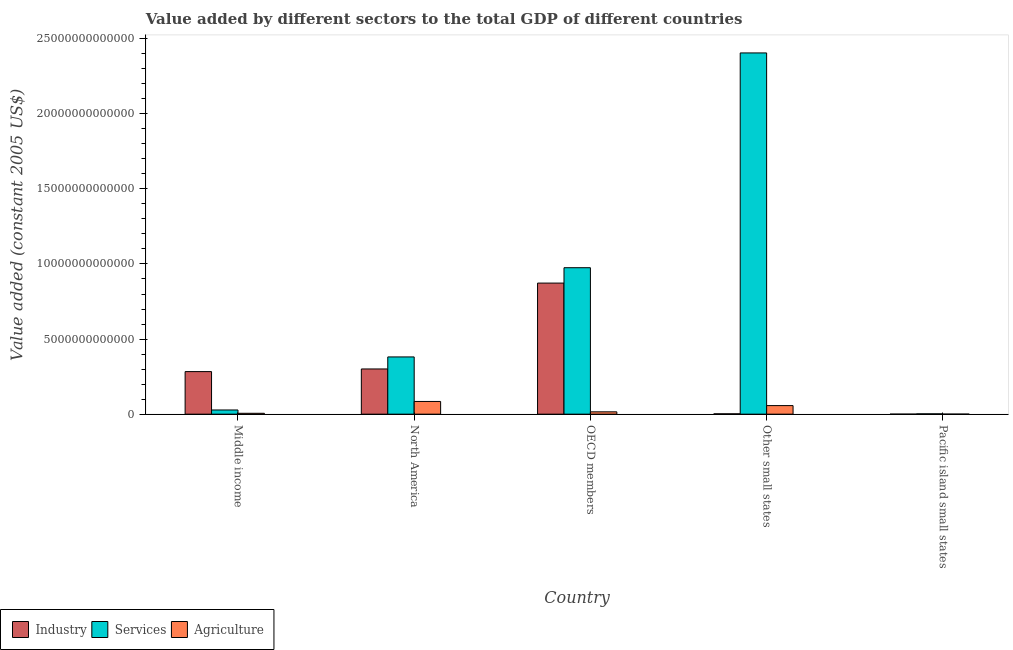How many different coloured bars are there?
Make the answer very short. 3. Are the number of bars per tick equal to the number of legend labels?
Your answer should be very brief. Yes. Are the number of bars on each tick of the X-axis equal?
Your response must be concise. Yes. How many bars are there on the 4th tick from the right?
Offer a very short reply. 3. What is the label of the 4th group of bars from the left?
Keep it short and to the point. Other small states. In how many cases, is the number of bars for a given country not equal to the number of legend labels?
Offer a terse response. 0. What is the value added by agricultural sector in Pacific island small states?
Make the answer very short. 3.43e+09. Across all countries, what is the maximum value added by industrial sector?
Give a very brief answer. 8.73e+12. Across all countries, what is the minimum value added by industrial sector?
Offer a terse response. 8.45e+08. In which country was the value added by agricultural sector maximum?
Provide a succinct answer. North America. In which country was the value added by industrial sector minimum?
Your answer should be compact. Pacific island small states. What is the total value added by agricultural sector in the graph?
Your answer should be very brief. 1.63e+12. What is the difference between the value added by industrial sector in North America and that in Pacific island small states?
Offer a terse response. 3.01e+12. What is the difference between the value added by industrial sector in Middle income and the value added by services in Other small states?
Give a very brief answer. -2.12e+13. What is the average value added by industrial sector per country?
Give a very brief answer. 2.92e+12. What is the difference between the value added by industrial sector and value added by agricultural sector in OECD members?
Provide a short and direct response. 8.57e+12. In how many countries, is the value added by services greater than 6000000000000 US$?
Provide a short and direct response. 2. What is the ratio of the value added by services in OECD members to that in Pacific island small states?
Your answer should be very brief. 452.85. Is the value added by services in OECD members less than that in Pacific island small states?
Offer a terse response. No. Is the difference between the value added by industrial sector in North America and Other small states greater than the difference between the value added by agricultural sector in North America and Other small states?
Offer a terse response. Yes. What is the difference between the highest and the second highest value added by services?
Offer a terse response. 1.43e+13. What is the difference between the highest and the lowest value added by agricultural sector?
Offer a very short reply. 8.42e+11. Is the sum of the value added by services in Middle income and North America greater than the maximum value added by industrial sector across all countries?
Your answer should be very brief. No. What does the 1st bar from the left in Pacific island small states represents?
Keep it short and to the point. Industry. What does the 1st bar from the right in Other small states represents?
Ensure brevity in your answer.  Agriculture. Is it the case that in every country, the sum of the value added by industrial sector and value added by services is greater than the value added by agricultural sector?
Give a very brief answer. Yes. Are all the bars in the graph horizontal?
Your answer should be compact. No. What is the difference between two consecutive major ticks on the Y-axis?
Your response must be concise. 5.00e+12. Does the graph contain any zero values?
Keep it short and to the point. No. Does the graph contain grids?
Provide a succinct answer. No. What is the title of the graph?
Ensure brevity in your answer.  Value added by different sectors to the total GDP of different countries. What is the label or title of the X-axis?
Provide a short and direct response. Country. What is the label or title of the Y-axis?
Offer a terse response. Value added (constant 2005 US$). What is the Value added (constant 2005 US$) in Industry in Middle income?
Offer a very short reply. 2.83e+12. What is the Value added (constant 2005 US$) of Services in Middle income?
Offer a terse response. 2.78e+11. What is the Value added (constant 2005 US$) of Agriculture in Middle income?
Provide a short and direct response. 5.82e+1. What is the Value added (constant 2005 US$) of Industry in North America?
Keep it short and to the point. 3.01e+12. What is the Value added (constant 2005 US$) of Services in North America?
Keep it short and to the point. 3.81e+12. What is the Value added (constant 2005 US$) of Agriculture in North America?
Your answer should be compact. 8.46e+11. What is the Value added (constant 2005 US$) of Industry in OECD members?
Your answer should be compact. 8.73e+12. What is the Value added (constant 2005 US$) of Services in OECD members?
Provide a succinct answer. 9.75e+12. What is the Value added (constant 2005 US$) of Agriculture in OECD members?
Your answer should be very brief. 1.55e+11. What is the Value added (constant 2005 US$) of Industry in Other small states?
Offer a very short reply. 2.33e+1. What is the Value added (constant 2005 US$) of Services in Other small states?
Keep it short and to the point. 2.41e+13. What is the Value added (constant 2005 US$) in Agriculture in Other small states?
Offer a very short reply. 5.71e+11. What is the Value added (constant 2005 US$) in Industry in Pacific island small states?
Keep it short and to the point. 8.45e+08. What is the Value added (constant 2005 US$) of Services in Pacific island small states?
Provide a short and direct response. 2.15e+1. What is the Value added (constant 2005 US$) in Agriculture in Pacific island small states?
Ensure brevity in your answer.  3.43e+09. Across all countries, what is the maximum Value added (constant 2005 US$) in Industry?
Provide a short and direct response. 8.73e+12. Across all countries, what is the maximum Value added (constant 2005 US$) in Services?
Give a very brief answer. 2.41e+13. Across all countries, what is the maximum Value added (constant 2005 US$) in Agriculture?
Give a very brief answer. 8.46e+11. Across all countries, what is the minimum Value added (constant 2005 US$) of Industry?
Offer a terse response. 8.45e+08. Across all countries, what is the minimum Value added (constant 2005 US$) of Services?
Offer a terse response. 2.15e+1. Across all countries, what is the minimum Value added (constant 2005 US$) in Agriculture?
Your answer should be very brief. 3.43e+09. What is the total Value added (constant 2005 US$) in Industry in the graph?
Provide a short and direct response. 1.46e+13. What is the total Value added (constant 2005 US$) of Services in the graph?
Make the answer very short. 3.79e+13. What is the total Value added (constant 2005 US$) in Agriculture in the graph?
Keep it short and to the point. 1.63e+12. What is the difference between the Value added (constant 2005 US$) in Industry in Middle income and that in North America?
Provide a succinct answer. -1.75e+11. What is the difference between the Value added (constant 2005 US$) of Services in Middle income and that in North America?
Your response must be concise. -3.53e+12. What is the difference between the Value added (constant 2005 US$) of Agriculture in Middle income and that in North America?
Offer a terse response. -7.87e+11. What is the difference between the Value added (constant 2005 US$) of Industry in Middle income and that in OECD members?
Provide a succinct answer. -5.89e+12. What is the difference between the Value added (constant 2005 US$) in Services in Middle income and that in OECD members?
Offer a terse response. -9.47e+12. What is the difference between the Value added (constant 2005 US$) of Agriculture in Middle income and that in OECD members?
Make the answer very short. -9.70e+1. What is the difference between the Value added (constant 2005 US$) in Industry in Middle income and that in Other small states?
Ensure brevity in your answer.  2.81e+12. What is the difference between the Value added (constant 2005 US$) of Services in Middle income and that in Other small states?
Your answer should be compact. -2.38e+13. What is the difference between the Value added (constant 2005 US$) in Agriculture in Middle income and that in Other small states?
Your answer should be compact. -5.12e+11. What is the difference between the Value added (constant 2005 US$) in Industry in Middle income and that in Pacific island small states?
Offer a very short reply. 2.83e+12. What is the difference between the Value added (constant 2005 US$) of Services in Middle income and that in Pacific island small states?
Provide a succinct answer. 2.57e+11. What is the difference between the Value added (constant 2005 US$) of Agriculture in Middle income and that in Pacific island small states?
Offer a very short reply. 5.48e+1. What is the difference between the Value added (constant 2005 US$) in Industry in North America and that in OECD members?
Your answer should be very brief. -5.72e+12. What is the difference between the Value added (constant 2005 US$) of Services in North America and that in OECD members?
Keep it short and to the point. -5.94e+12. What is the difference between the Value added (constant 2005 US$) of Agriculture in North America and that in OECD members?
Your answer should be compact. 6.90e+11. What is the difference between the Value added (constant 2005 US$) in Industry in North America and that in Other small states?
Offer a terse response. 2.99e+12. What is the difference between the Value added (constant 2005 US$) in Services in North America and that in Other small states?
Offer a very short reply. -2.02e+13. What is the difference between the Value added (constant 2005 US$) in Agriculture in North America and that in Other small states?
Keep it short and to the point. 2.75e+11. What is the difference between the Value added (constant 2005 US$) in Industry in North America and that in Pacific island small states?
Keep it short and to the point. 3.01e+12. What is the difference between the Value added (constant 2005 US$) in Services in North America and that in Pacific island small states?
Ensure brevity in your answer.  3.79e+12. What is the difference between the Value added (constant 2005 US$) of Agriculture in North America and that in Pacific island small states?
Ensure brevity in your answer.  8.42e+11. What is the difference between the Value added (constant 2005 US$) in Industry in OECD members and that in Other small states?
Your response must be concise. 8.70e+12. What is the difference between the Value added (constant 2005 US$) in Services in OECD members and that in Other small states?
Ensure brevity in your answer.  -1.43e+13. What is the difference between the Value added (constant 2005 US$) in Agriculture in OECD members and that in Other small states?
Your answer should be very brief. -4.15e+11. What is the difference between the Value added (constant 2005 US$) of Industry in OECD members and that in Pacific island small states?
Keep it short and to the point. 8.73e+12. What is the difference between the Value added (constant 2005 US$) of Services in OECD members and that in Pacific island small states?
Your answer should be very brief. 9.73e+12. What is the difference between the Value added (constant 2005 US$) of Agriculture in OECD members and that in Pacific island small states?
Your response must be concise. 1.52e+11. What is the difference between the Value added (constant 2005 US$) of Industry in Other small states and that in Pacific island small states?
Your answer should be very brief. 2.24e+1. What is the difference between the Value added (constant 2005 US$) in Services in Other small states and that in Pacific island small states?
Your response must be concise. 2.40e+13. What is the difference between the Value added (constant 2005 US$) of Agriculture in Other small states and that in Pacific island small states?
Your answer should be very brief. 5.67e+11. What is the difference between the Value added (constant 2005 US$) of Industry in Middle income and the Value added (constant 2005 US$) of Services in North America?
Ensure brevity in your answer.  -9.76e+11. What is the difference between the Value added (constant 2005 US$) in Industry in Middle income and the Value added (constant 2005 US$) in Agriculture in North America?
Offer a very short reply. 1.99e+12. What is the difference between the Value added (constant 2005 US$) of Services in Middle income and the Value added (constant 2005 US$) of Agriculture in North America?
Provide a short and direct response. -5.67e+11. What is the difference between the Value added (constant 2005 US$) of Industry in Middle income and the Value added (constant 2005 US$) of Services in OECD members?
Provide a succinct answer. -6.92e+12. What is the difference between the Value added (constant 2005 US$) of Industry in Middle income and the Value added (constant 2005 US$) of Agriculture in OECD members?
Offer a very short reply. 2.68e+12. What is the difference between the Value added (constant 2005 US$) of Services in Middle income and the Value added (constant 2005 US$) of Agriculture in OECD members?
Ensure brevity in your answer.  1.23e+11. What is the difference between the Value added (constant 2005 US$) of Industry in Middle income and the Value added (constant 2005 US$) of Services in Other small states?
Provide a short and direct response. -2.12e+13. What is the difference between the Value added (constant 2005 US$) of Industry in Middle income and the Value added (constant 2005 US$) of Agriculture in Other small states?
Provide a succinct answer. 2.26e+12. What is the difference between the Value added (constant 2005 US$) in Services in Middle income and the Value added (constant 2005 US$) in Agriculture in Other small states?
Give a very brief answer. -2.92e+11. What is the difference between the Value added (constant 2005 US$) in Industry in Middle income and the Value added (constant 2005 US$) in Services in Pacific island small states?
Offer a very short reply. 2.81e+12. What is the difference between the Value added (constant 2005 US$) of Industry in Middle income and the Value added (constant 2005 US$) of Agriculture in Pacific island small states?
Make the answer very short. 2.83e+12. What is the difference between the Value added (constant 2005 US$) of Services in Middle income and the Value added (constant 2005 US$) of Agriculture in Pacific island small states?
Provide a succinct answer. 2.75e+11. What is the difference between the Value added (constant 2005 US$) in Industry in North America and the Value added (constant 2005 US$) in Services in OECD members?
Offer a very short reply. -6.74e+12. What is the difference between the Value added (constant 2005 US$) of Industry in North America and the Value added (constant 2005 US$) of Agriculture in OECD members?
Offer a terse response. 2.85e+12. What is the difference between the Value added (constant 2005 US$) of Services in North America and the Value added (constant 2005 US$) of Agriculture in OECD members?
Provide a succinct answer. 3.66e+12. What is the difference between the Value added (constant 2005 US$) in Industry in North America and the Value added (constant 2005 US$) in Services in Other small states?
Your answer should be compact. -2.10e+13. What is the difference between the Value added (constant 2005 US$) in Industry in North America and the Value added (constant 2005 US$) in Agriculture in Other small states?
Make the answer very short. 2.44e+12. What is the difference between the Value added (constant 2005 US$) of Services in North America and the Value added (constant 2005 US$) of Agriculture in Other small states?
Your answer should be very brief. 3.24e+12. What is the difference between the Value added (constant 2005 US$) in Industry in North America and the Value added (constant 2005 US$) in Services in Pacific island small states?
Make the answer very short. 2.99e+12. What is the difference between the Value added (constant 2005 US$) in Industry in North America and the Value added (constant 2005 US$) in Agriculture in Pacific island small states?
Provide a short and direct response. 3.01e+12. What is the difference between the Value added (constant 2005 US$) of Services in North America and the Value added (constant 2005 US$) of Agriculture in Pacific island small states?
Your answer should be compact. 3.81e+12. What is the difference between the Value added (constant 2005 US$) in Industry in OECD members and the Value added (constant 2005 US$) in Services in Other small states?
Ensure brevity in your answer.  -1.53e+13. What is the difference between the Value added (constant 2005 US$) of Industry in OECD members and the Value added (constant 2005 US$) of Agriculture in Other small states?
Provide a short and direct response. 8.16e+12. What is the difference between the Value added (constant 2005 US$) of Services in OECD members and the Value added (constant 2005 US$) of Agriculture in Other small states?
Provide a succinct answer. 9.18e+12. What is the difference between the Value added (constant 2005 US$) in Industry in OECD members and the Value added (constant 2005 US$) in Services in Pacific island small states?
Your response must be concise. 8.71e+12. What is the difference between the Value added (constant 2005 US$) of Industry in OECD members and the Value added (constant 2005 US$) of Agriculture in Pacific island small states?
Offer a very short reply. 8.72e+12. What is the difference between the Value added (constant 2005 US$) of Services in OECD members and the Value added (constant 2005 US$) of Agriculture in Pacific island small states?
Make the answer very short. 9.75e+12. What is the difference between the Value added (constant 2005 US$) in Industry in Other small states and the Value added (constant 2005 US$) in Services in Pacific island small states?
Your answer should be compact. 1.75e+09. What is the difference between the Value added (constant 2005 US$) of Industry in Other small states and the Value added (constant 2005 US$) of Agriculture in Pacific island small states?
Give a very brief answer. 1.99e+1. What is the difference between the Value added (constant 2005 US$) in Services in Other small states and the Value added (constant 2005 US$) in Agriculture in Pacific island small states?
Your answer should be very brief. 2.40e+13. What is the average Value added (constant 2005 US$) in Industry per country?
Your answer should be compact. 2.92e+12. What is the average Value added (constant 2005 US$) of Services per country?
Provide a short and direct response. 7.58e+12. What is the average Value added (constant 2005 US$) in Agriculture per country?
Give a very brief answer. 3.27e+11. What is the difference between the Value added (constant 2005 US$) in Industry and Value added (constant 2005 US$) in Services in Middle income?
Keep it short and to the point. 2.56e+12. What is the difference between the Value added (constant 2005 US$) in Industry and Value added (constant 2005 US$) in Agriculture in Middle income?
Your answer should be compact. 2.78e+12. What is the difference between the Value added (constant 2005 US$) in Services and Value added (constant 2005 US$) in Agriculture in Middle income?
Give a very brief answer. 2.20e+11. What is the difference between the Value added (constant 2005 US$) of Industry and Value added (constant 2005 US$) of Services in North America?
Your answer should be very brief. -8.01e+11. What is the difference between the Value added (constant 2005 US$) in Industry and Value added (constant 2005 US$) in Agriculture in North America?
Provide a short and direct response. 2.16e+12. What is the difference between the Value added (constant 2005 US$) of Services and Value added (constant 2005 US$) of Agriculture in North America?
Ensure brevity in your answer.  2.96e+12. What is the difference between the Value added (constant 2005 US$) in Industry and Value added (constant 2005 US$) in Services in OECD members?
Offer a very short reply. -1.02e+12. What is the difference between the Value added (constant 2005 US$) of Industry and Value added (constant 2005 US$) of Agriculture in OECD members?
Provide a short and direct response. 8.57e+12. What is the difference between the Value added (constant 2005 US$) of Services and Value added (constant 2005 US$) of Agriculture in OECD members?
Provide a short and direct response. 9.60e+12. What is the difference between the Value added (constant 2005 US$) of Industry and Value added (constant 2005 US$) of Services in Other small states?
Offer a very short reply. -2.40e+13. What is the difference between the Value added (constant 2005 US$) in Industry and Value added (constant 2005 US$) in Agriculture in Other small states?
Your answer should be very brief. -5.47e+11. What is the difference between the Value added (constant 2005 US$) of Services and Value added (constant 2005 US$) of Agriculture in Other small states?
Your response must be concise. 2.35e+13. What is the difference between the Value added (constant 2005 US$) of Industry and Value added (constant 2005 US$) of Services in Pacific island small states?
Offer a very short reply. -2.07e+1. What is the difference between the Value added (constant 2005 US$) in Industry and Value added (constant 2005 US$) in Agriculture in Pacific island small states?
Provide a short and direct response. -2.59e+09. What is the difference between the Value added (constant 2005 US$) of Services and Value added (constant 2005 US$) of Agriculture in Pacific island small states?
Offer a terse response. 1.81e+1. What is the ratio of the Value added (constant 2005 US$) of Industry in Middle income to that in North America?
Your answer should be very brief. 0.94. What is the ratio of the Value added (constant 2005 US$) in Services in Middle income to that in North America?
Your response must be concise. 0.07. What is the ratio of the Value added (constant 2005 US$) in Agriculture in Middle income to that in North America?
Keep it short and to the point. 0.07. What is the ratio of the Value added (constant 2005 US$) of Industry in Middle income to that in OECD members?
Your answer should be very brief. 0.32. What is the ratio of the Value added (constant 2005 US$) in Services in Middle income to that in OECD members?
Your response must be concise. 0.03. What is the ratio of the Value added (constant 2005 US$) of Agriculture in Middle income to that in OECD members?
Provide a short and direct response. 0.37. What is the ratio of the Value added (constant 2005 US$) in Industry in Middle income to that in Other small states?
Make the answer very short. 121.73. What is the ratio of the Value added (constant 2005 US$) of Services in Middle income to that in Other small states?
Provide a succinct answer. 0.01. What is the ratio of the Value added (constant 2005 US$) in Agriculture in Middle income to that in Other small states?
Keep it short and to the point. 0.1. What is the ratio of the Value added (constant 2005 US$) in Industry in Middle income to that in Pacific island small states?
Provide a short and direct response. 3355.88. What is the ratio of the Value added (constant 2005 US$) of Services in Middle income to that in Pacific island small states?
Keep it short and to the point. 12.93. What is the ratio of the Value added (constant 2005 US$) of Agriculture in Middle income to that in Pacific island small states?
Provide a succinct answer. 16.97. What is the ratio of the Value added (constant 2005 US$) in Industry in North America to that in OECD members?
Provide a short and direct response. 0.34. What is the ratio of the Value added (constant 2005 US$) of Services in North America to that in OECD members?
Ensure brevity in your answer.  0.39. What is the ratio of the Value added (constant 2005 US$) of Agriculture in North America to that in OECD members?
Give a very brief answer. 5.45. What is the ratio of the Value added (constant 2005 US$) of Industry in North America to that in Other small states?
Ensure brevity in your answer.  129.26. What is the ratio of the Value added (constant 2005 US$) in Services in North America to that in Other small states?
Offer a very short reply. 0.16. What is the ratio of the Value added (constant 2005 US$) of Agriculture in North America to that in Other small states?
Offer a terse response. 1.48. What is the ratio of the Value added (constant 2005 US$) in Industry in North America to that in Pacific island small states?
Ensure brevity in your answer.  3563.5. What is the ratio of the Value added (constant 2005 US$) of Services in North America to that in Pacific island small states?
Your answer should be compact. 176.96. What is the ratio of the Value added (constant 2005 US$) of Agriculture in North America to that in Pacific island small states?
Make the answer very short. 246.51. What is the ratio of the Value added (constant 2005 US$) in Industry in OECD members to that in Other small states?
Ensure brevity in your answer.  374.83. What is the ratio of the Value added (constant 2005 US$) of Services in OECD members to that in Other small states?
Make the answer very short. 0.41. What is the ratio of the Value added (constant 2005 US$) of Agriculture in OECD members to that in Other small states?
Ensure brevity in your answer.  0.27. What is the ratio of the Value added (constant 2005 US$) in Industry in OECD members to that in Pacific island small states?
Keep it short and to the point. 1.03e+04. What is the ratio of the Value added (constant 2005 US$) in Services in OECD members to that in Pacific island small states?
Give a very brief answer. 452.85. What is the ratio of the Value added (constant 2005 US$) of Agriculture in OECD members to that in Pacific island small states?
Your response must be concise. 45.27. What is the ratio of the Value added (constant 2005 US$) in Industry in Other small states to that in Pacific island small states?
Your answer should be very brief. 27.57. What is the ratio of the Value added (constant 2005 US$) in Services in Other small states to that in Pacific island small states?
Offer a terse response. 1116.94. What is the ratio of the Value added (constant 2005 US$) in Agriculture in Other small states to that in Pacific island small states?
Your response must be concise. 166.34. What is the difference between the highest and the second highest Value added (constant 2005 US$) in Industry?
Provide a succinct answer. 5.72e+12. What is the difference between the highest and the second highest Value added (constant 2005 US$) in Services?
Your answer should be very brief. 1.43e+13. What is the difference between the highest and the second highest Value added (constant 2005 US$) in Agriculture?
Your answer should be compact. 2.75e+11. What is the difference between the highest and the lowest Value added (constant 2005 US$) in Industry?
Offer a terse response. 8.73e+12. What is the difference between the highest and the lowest Value added (constant 2005 US$) of Services?
Offer a very short reply. 2.40e+13. What is the difference between the highest and the lowest Value added (constant 2005 US$) in Agriculture?
Ensure brevity in your answer.  8.42e+11. 